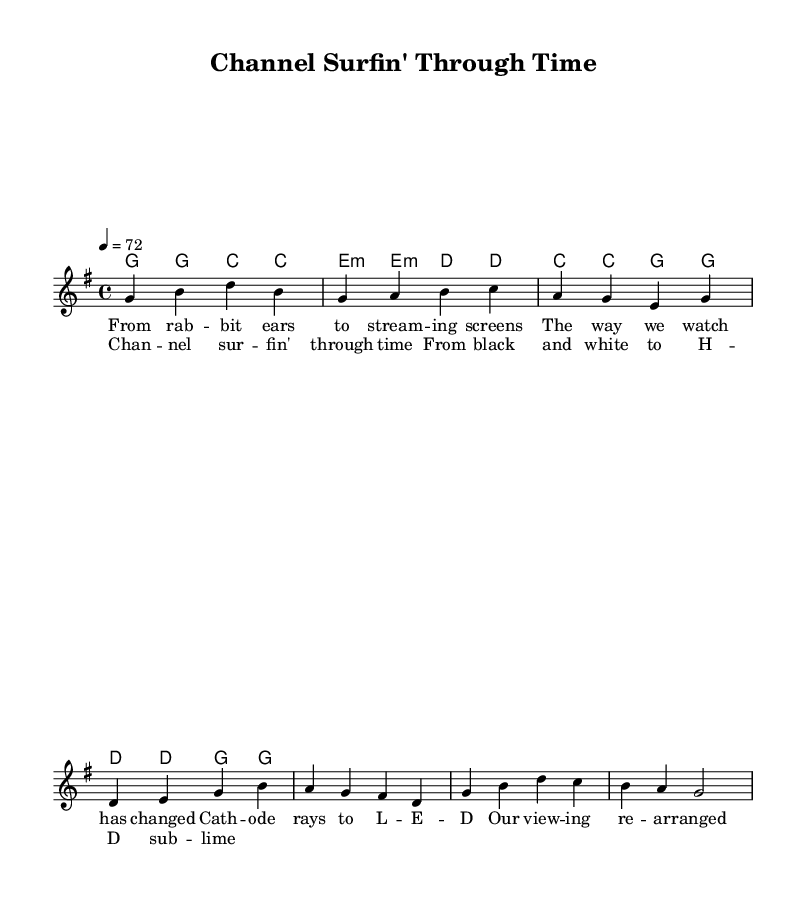What is the key signature of this music? The key signature is G major, which has one sharp (F#). This can be identified at the beginning of the score where the key signature is notated.
Answer: G major What is the time signature of the piece? The time signature is 4/4, which indicates that there are four beats in each measure and the quarter note gets one beat. This is shown at the beginning of the score.
Answer: 4/4 What is the tempo marking for this music? The tempo marking is 72 beats per minute, as indicated at the beginning of the score with the tempo directive.
Answer: 72 How many measures are in the verse section? The verse section consists of four measures, which can be counted through the lyric annotations under the melody and chord symbols.
Answer: 4 What is the primary theme of the lyrics? The primary theme of the lyrics reflects the evolution of how we consume media, starting from older technologies to modern streaming platforms. This can be interpreted through the lyrics provided, which mention "rab bit ears" and "streaming screens."
Answer: Evolution of media Which chord appears most frequently in the verse? The G major chord appears most frequently, as noted in the chord structure written above the melody in the verse section.
Answer: G major 